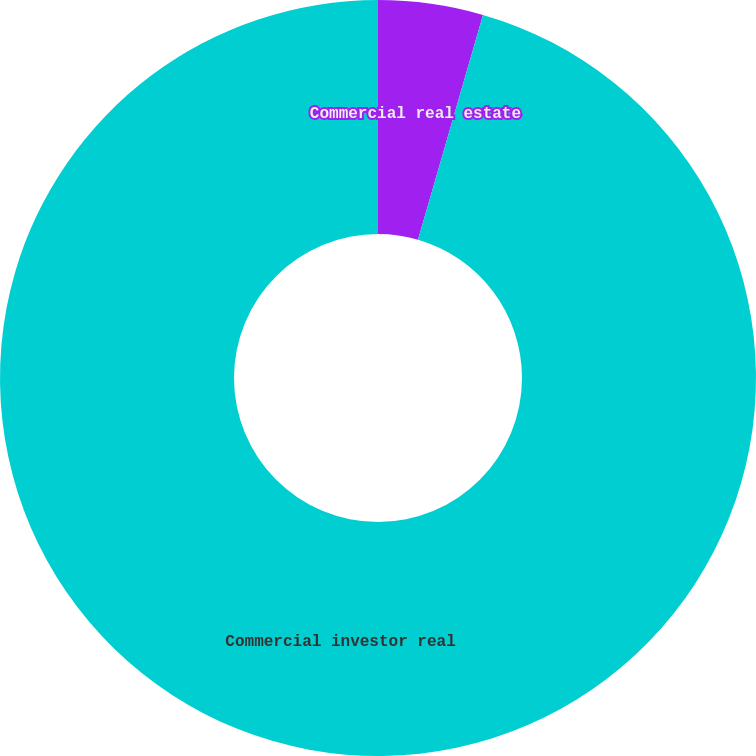Convert chart. <chart><loc_0><loc_0><loc_500><loc_500><pie_chart><fcel>Commercial real estate<fcel>Commercial investor real<nl><fcel>4.48%<fcel>95.52%<nl></chart> 